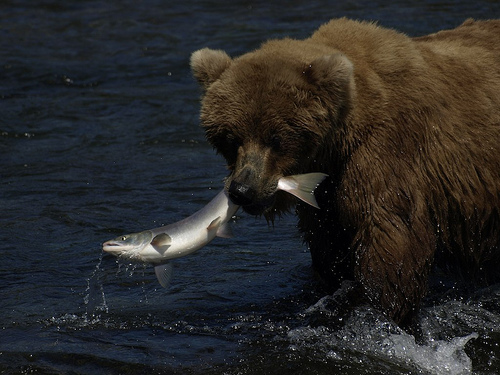Can you describe the activity the bear is engaged in? Certainly! The bear is engaged in fishing, a common behavior for brown bears, especially during salmon runs where fish are plentiful. 